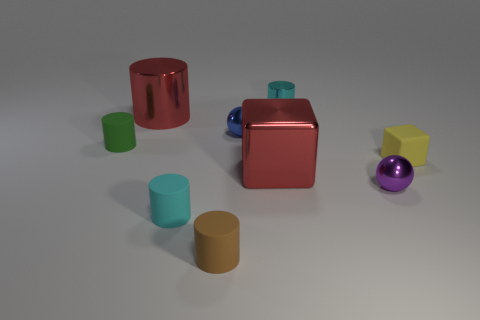Subtract 2 cylinders. How many cylinders are left? 3 Subtract all brown cylinders. How many cylinders are left? 4 Subtract all purple balls. Subtract all brown cylinders. How many balls are left? 1 Add 1 yellow matte spheres. How many objects exist? 10 Subtract all cylinders. How many objects are left? 4 Add 6 big red things. How many big red things exist? 8 Subtract 1 red cubes. How many objects are left? 8 Subtract all purple metallic things. Subtract all large cylinders. How many objects are left? 7 Add 8 tiny brown cylinders. How many tiny brown cylinders are left? 9 